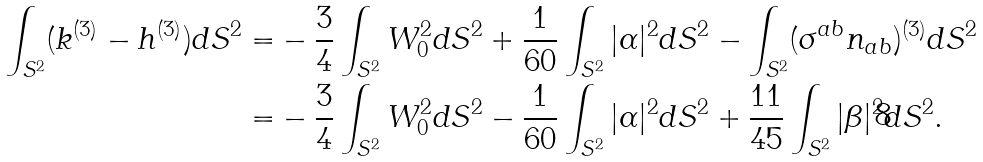<formula> <loc_0><loc_0><loc_500><loc_500>\int _ { S ^ { 2 } } ( k ^ { ( 3 ) } - h ^ { ( 3 ) } ) d S ^ { 2 } = & - \frac { 3 } { 4 } \int _ { S ^ { 2 } } W _ { 0 } ^ { 2 } d S ^ { 2 } + \frac { 1 } { 6 0 } \int _ { S ^ { 2 } } | \alpha | ^ { 2 } d S ^ { 2 } - \int _ { S ^ { 2 } } ( \sigma ^ { a b } n _ { a b } ) ^ { ( 3 ) } d S ^ { 2 } \\ = & - \frac { 3 } { 4 } \int _ { S ^ { 2 } } W _ { 0 } ^ { 2 } d S ^ { 2 } - \frac { 1 } { 6 0 } \int _ { S ^ { 2 } } | \alpha | ^ { 2 } d S ^ { 2 } + \frac { 1 1 } { 4 5 } \int _ { S ^ { 2 } } | \beta | ^ { 2 } d S ^ { 2 } .</formula> 